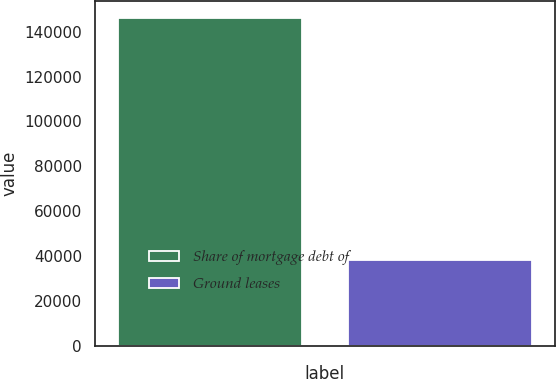Convert chart. <chart><loc_0><loc_0><loc_500><loc_500><bar_chart><fcel>Share of mortgage debt of<fcel>Ground leases<nl><fcel>146296<fcel>38115<nl></chart> 